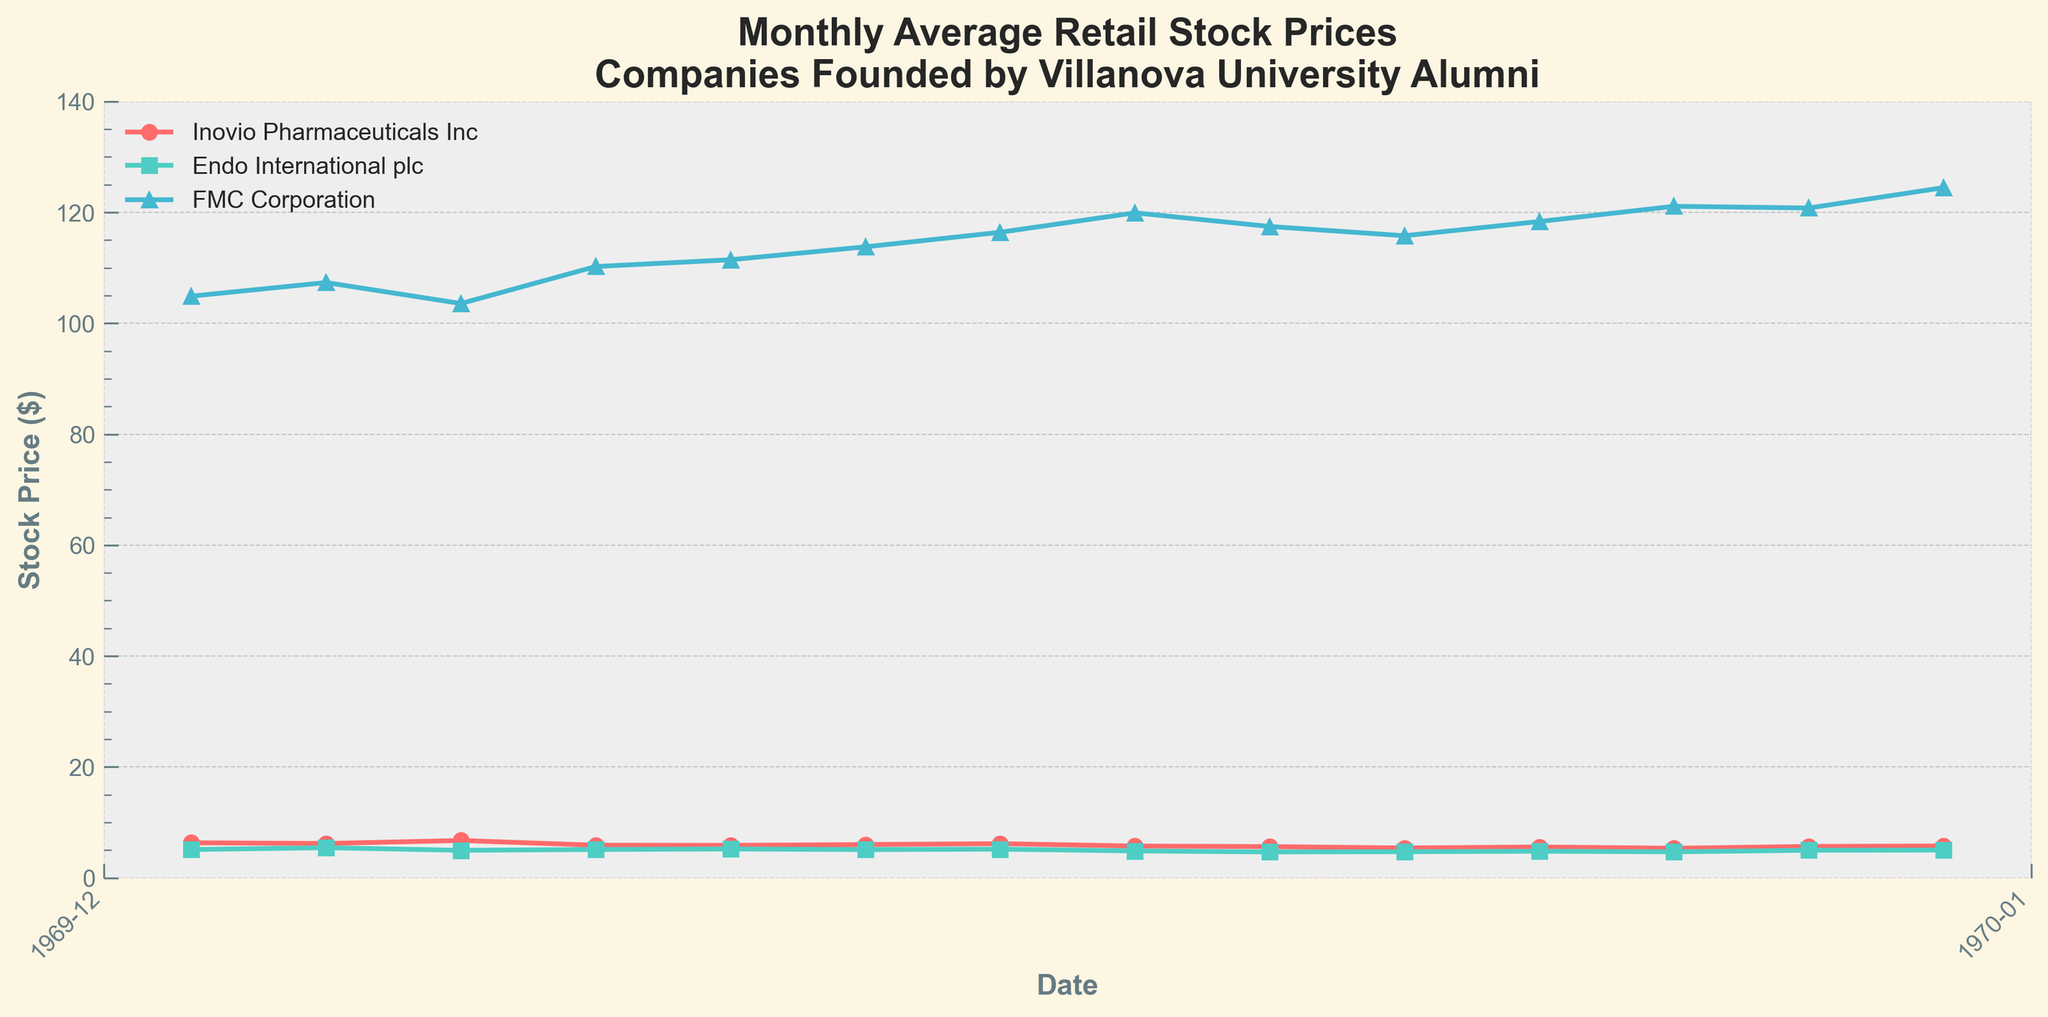What is the title of the plot? The title is displayed at the top of the plot in bold letters.
Answer: Monthly Average Retail Stock Prices - Companies Founded by Villanova University Alumni Which company had the highest stock price in January 2023? The highest stock price in January 2023 can be determined by comparing the stock prices in that month for each company. FMC Corporation has the highest price at $120.78.
Answer: FMC Corporation How did the stock price of Endo International plc change from February 2022 to August 2022? The initial price in February 2022 was $5.45, and the final price in August 2022 was $4.87. Subtracting the final price from the initial price: $5.45 - $4.87 = $0.58 decrease.
Answer: Decreased by $0.58 Which company showed the most increase in stock price from October 2022 to February 2023? Calculating the increase for each company between the two months: Inovio Pharmaceuticals Inc: $5.76 - $5.40 = $0.36, Endo International plc: $5.02 - $4.73 = $0.29, FMC Corporation: $124.45 - $115.78 = $8.67. FMC Corporation showed the most increase.
Answer: FMC Corporation What is the average stock price of Inovio Pharmaceuticals Inc over the entire period displayed? Summing the stock prices for Inovio Pharmaceuticals Inc and dividing by the number of months (13): (6.34 + 6.21 + 6.75 + 5.90 + 5.87 + 6.02 + 6.18 + 5.75 + 5.65 + 5.40 + 5.58 + 5.35 + 5.68 + 5.76) / 14 = 84.44 / 14.
Answer: $6.03 Which month had the lowest stock price for FMC Corporation? The lowest price can be spotted by examining the monthly data points for FMC Corporation. The lowest stock price is in March 2022 at $103.56.
Answer: March 2022 Did Endo International plc's stock price ever increase consecutively for three months? Reviewing the plot and the provided data reveals that Endo International plc’s stock price did not increase for three consecutive months at any time.
Answer: No By how much did the stock price of Inovio Pharmaceuticals Inc decrease from its highest point to its lowest point? The highest stock price was $6.75 in March 2022, and the lowest was $5.35 in December 2022. The decrease is calculated as $6.75 - $5.35 = $1.40.
Answer: $1.40 Which company had the steadiest stock price over the period shown? A visual examination shows that Endo International plc had the least variation in its stock price compared to the other two companies.
Answer: Endo International plc What was the stock price trend for FMC Corporation from May 2022 to September 2022? In May 2022, the price was $111.45, and it increased each month up to $119.91 in August before dropping to $117.45 in September.
Answer: Increasing trend followed by a slight decrease 